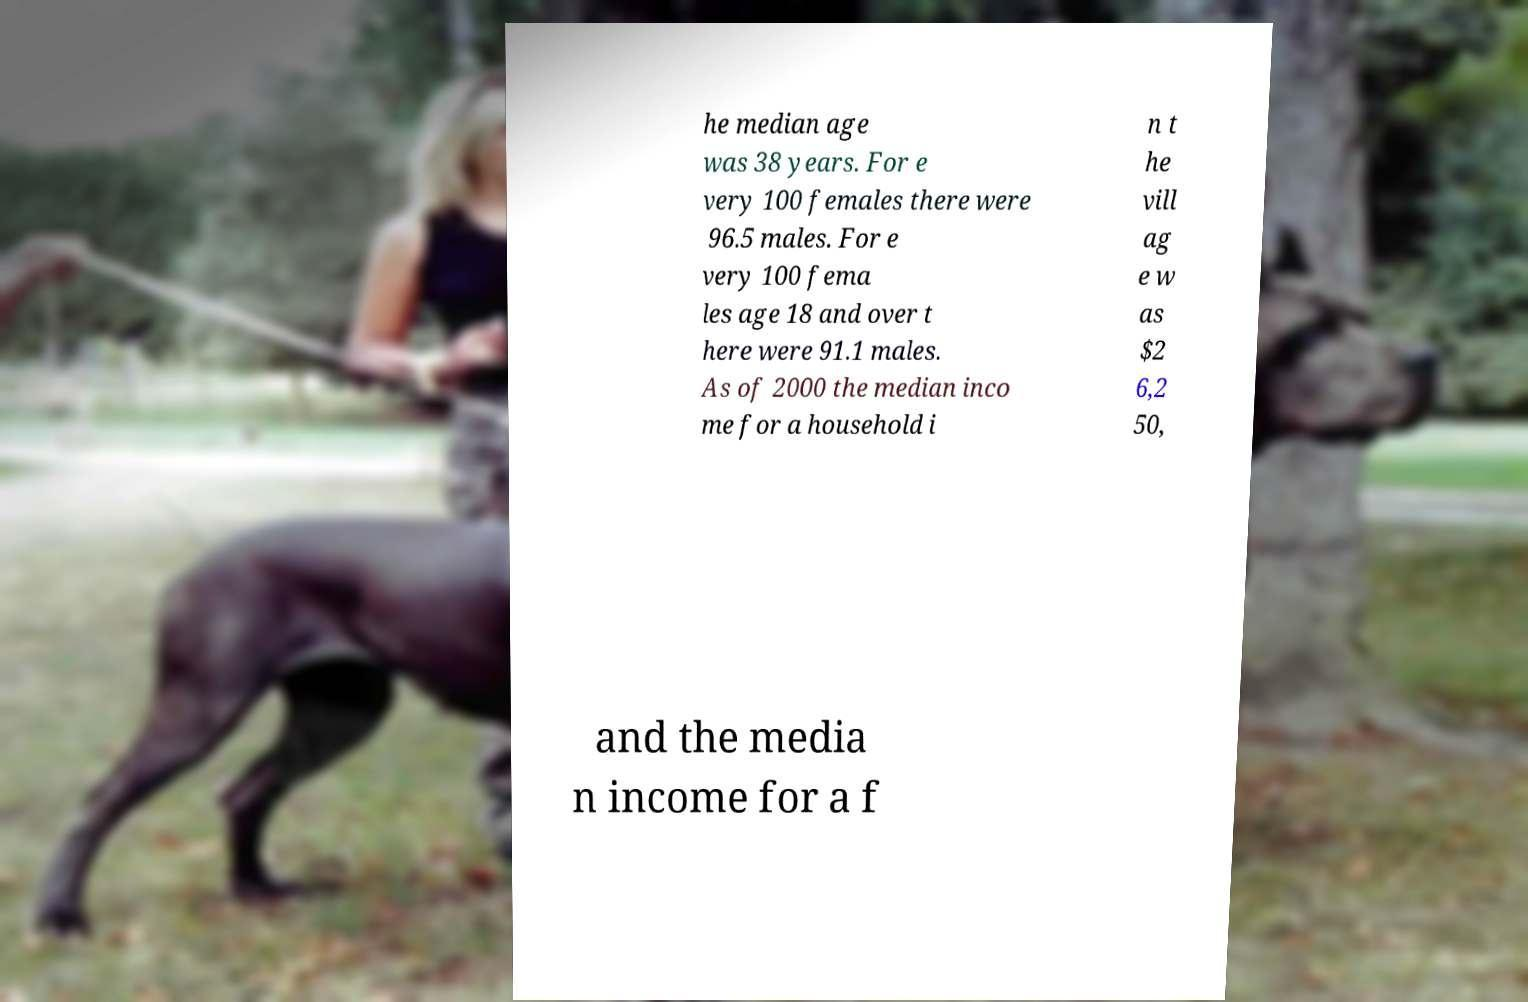Can you read and provide the text displayed in the image?This photo seems to have some interesting text. Can you extract and type it out for me? he median age was 38 years. For e very 100 females there were 96.5 males. For e very 100 fema les age 18 and over t here were 91.1 males. As of 2000 the median inco me for a household i n t he vill ag e w as $2 6,2 50, and the media n income for a f 